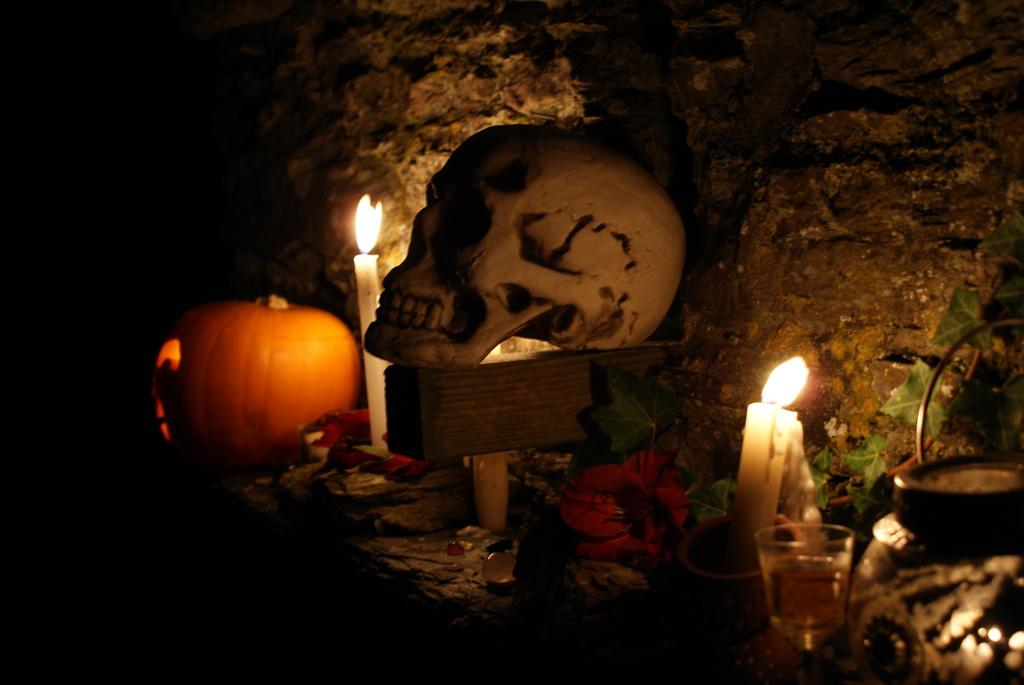What is placed on the wooden brick in the image? There is a skull on a wooden brick in the image. What can be seen in the image that provides light? There are candles in the image. What type of vegetation is present in the image? There is a plant in the image. What decorative elements can be seen in the image? There are flowers and a pumpkin in the image. What object might be used for drinking in the image? There is a glass in the image. What is visible in the background of the image? There is a wall in the background of the image. What type of toe treatment is being performed in the image? There is no toe treatment being performed in the image; it features a skull, candles, a plant, flowers, a pumpkin, a glass, and a wall in the background. Is there anyone driving a vehicle in the image? There is no vehicle or person driving in the image. 